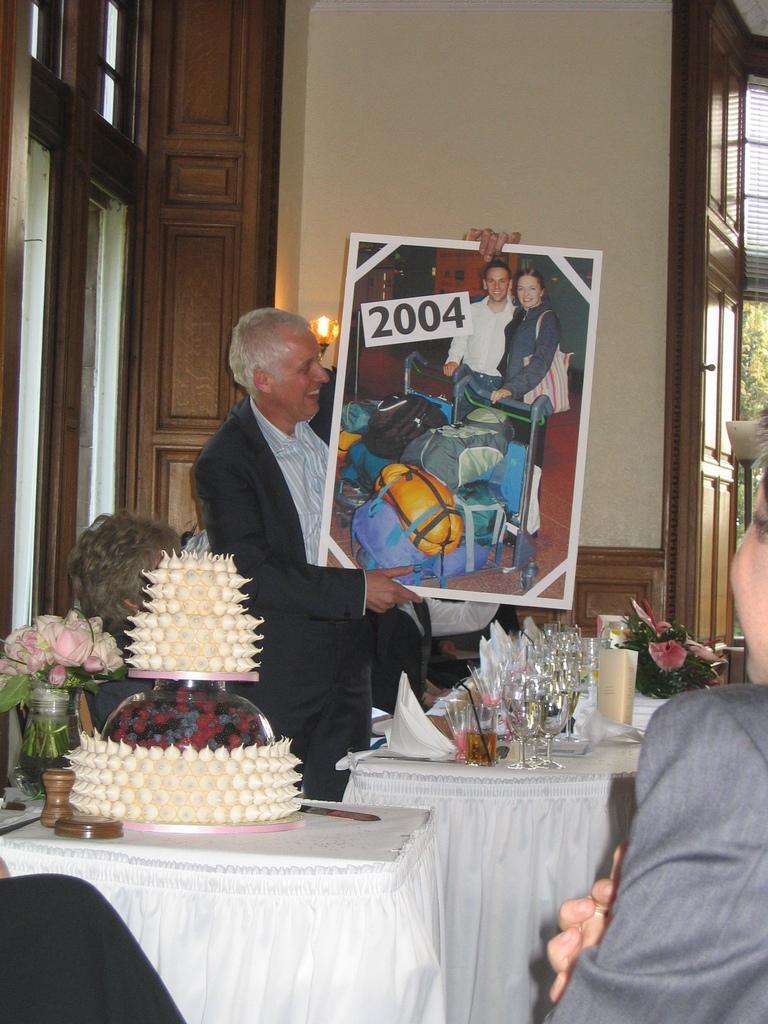Could you give a brief overview of what you see in this image? A man is standing and holding a picture photograph in that it's 2004 there are glasses and food items on the tables behind him there is a light on the wall and the left it's a door wall. 